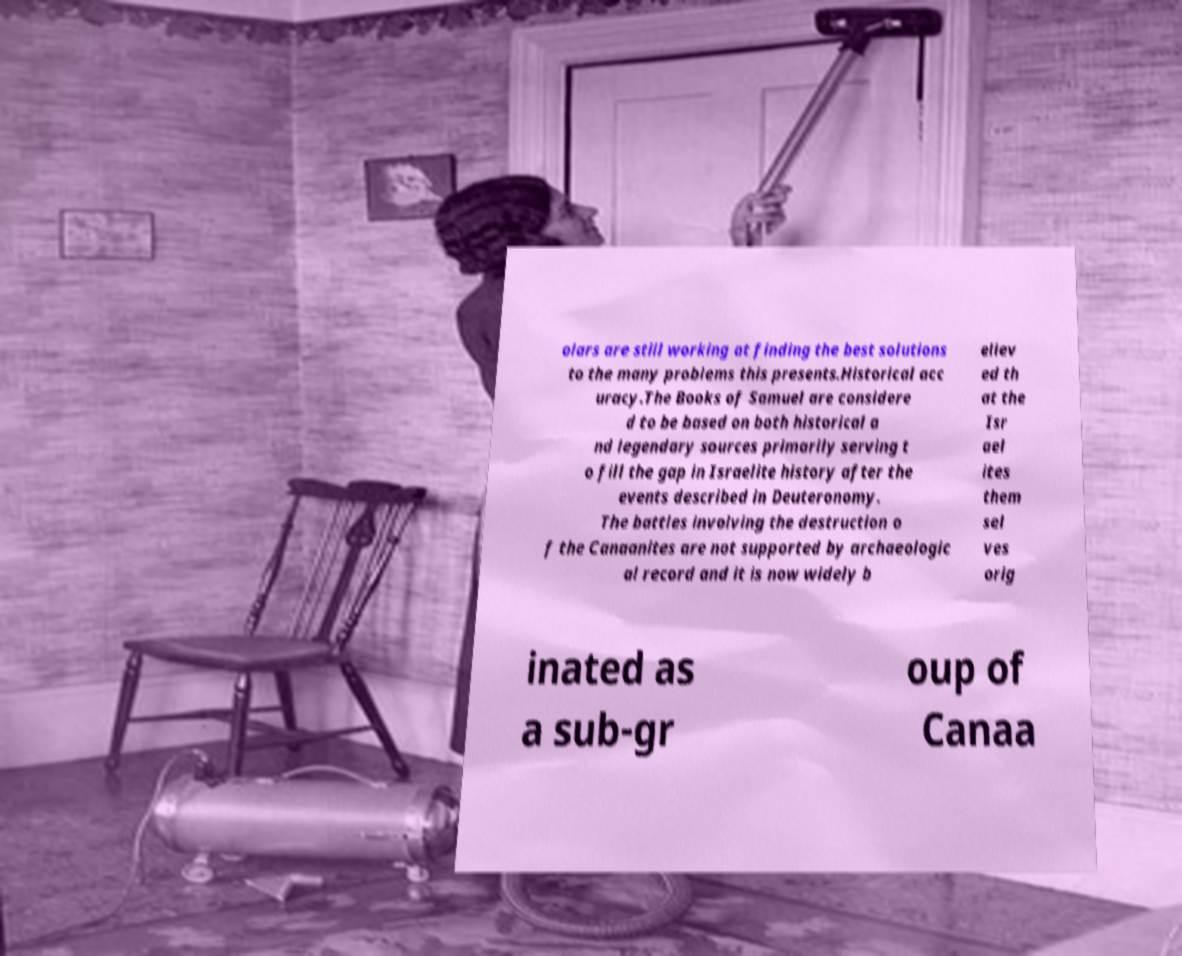For documentation purposes, I need the text within this image transcribed. Could you provide that? olars are still working at finding the best solutions to the many problems this presents.Historical acc uracy.The Books of Samuel are considere d to be based on both historical a nd legendary sources primarily serving t o fill the gap in Israelite history after the events described in Deuteronomy. The battles involving the destruction o f the Canaanites are not supported by archaeologic al record and it is now widely b eliev ed th at the Isr ael ites them sel ves orig inated as a sub-gr oup of Canaa 